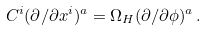Convert formula to latex. <formula><loc_0><loc_0><loc_500><loc_500>C ^ { i } ( \partial / \partial x ^ { i } ) ^ { a } = \Omega _ { H } ( \partial / \partial \phi ) ^ { a } \, .</formula> 